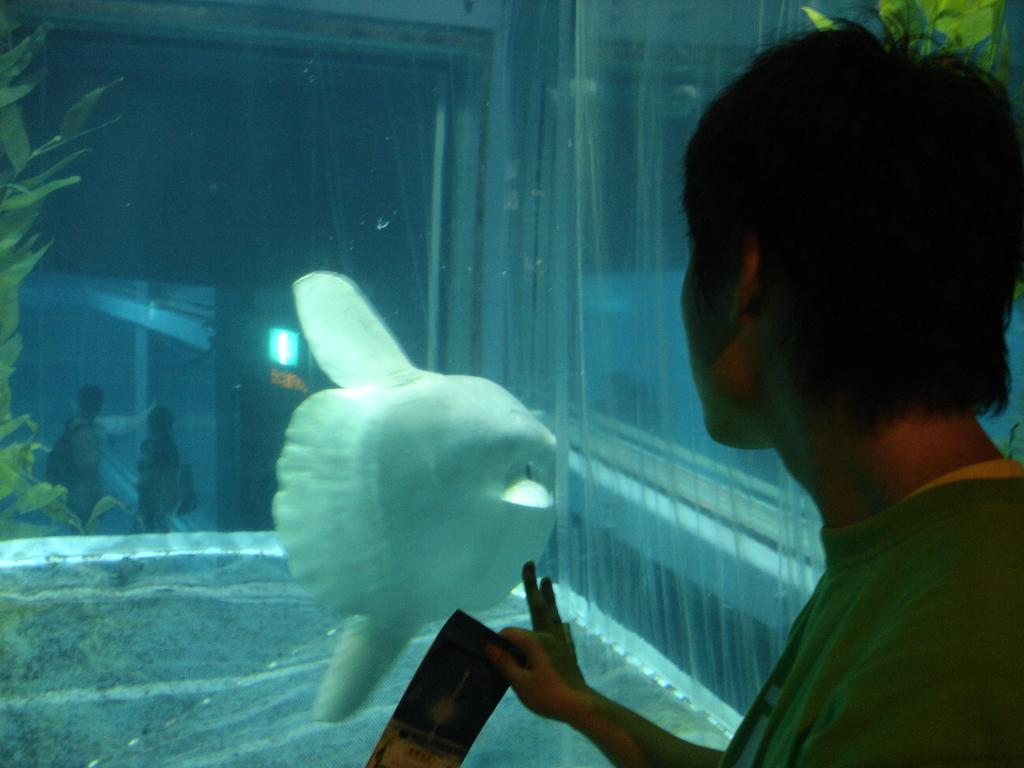What type of animal can be seen in the water in the image? There is a fish in the water in the image. What else can be seen in the image besides the fish? There are plants visible in the image. Are there any people present in the image? Yes, there are people standing in the image. What hobbies do the people in the image have? There is no information about the people's hobbies in the image. What type of shirt is the fish wearing in the image? Fish do not wear shirts, and there is no shirt present in the image. 